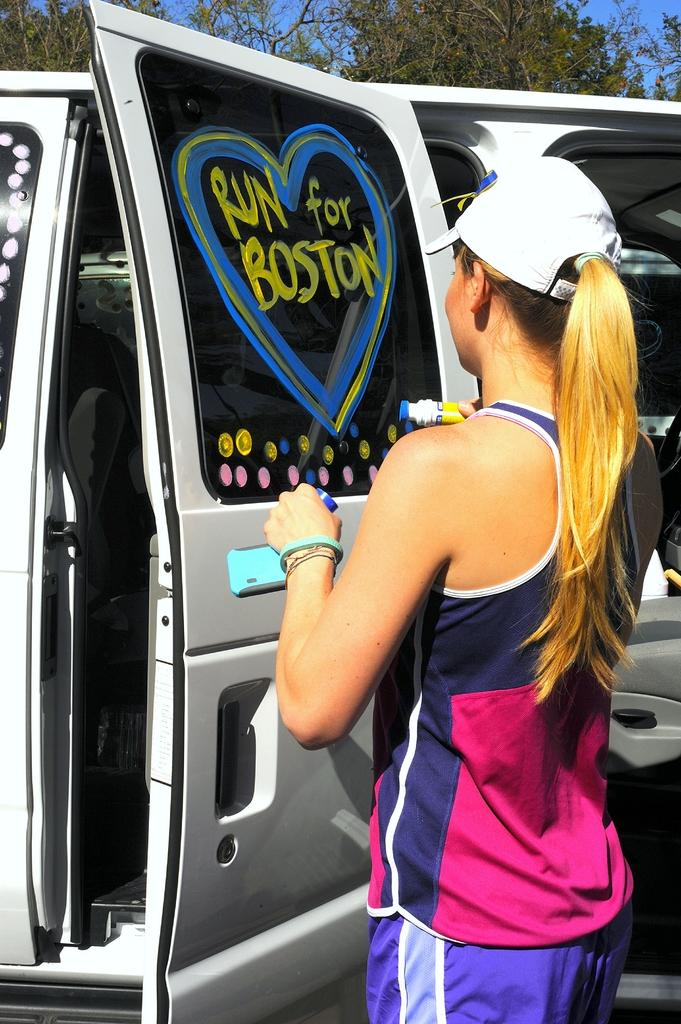What is the person holding in the image? The information provided does not specify what the person is holding. What type of vehicle can be seen in the image? There is a vehicle visible in the image, but the specific type is not mentioned. What type of vegetation is present in the image? There are trees in the image. What is visible in the background of the image? The sky is visible in the image. Can you describe the zephyr in the image? There is no mention of a zephyr in the image. A zephyr is a gentle breeze, and it is not a visible object that can be described in an image. 